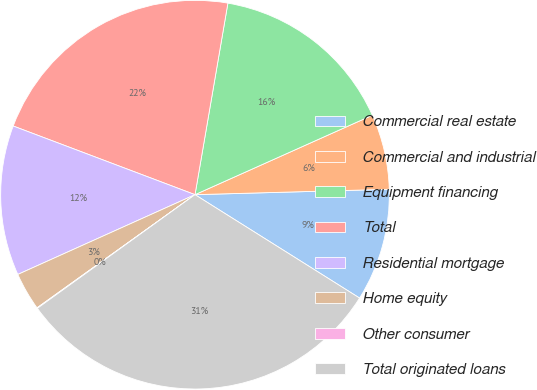Convert chart. <chart><loc_0><loc_0><loc_500><loc_500><pie_chart><fcel>Commercial real estate<fcel>Commercial and industrial<fcel>Equipment financing<fcel>Total<fcel>Residential mortgage<fcel>Home equity<fcel>Other consumer<fcel>Total originated loans<nl><fcel>9.37%<fcel>6.26%<fcel>15.59%<fcel>21.96%<fcel>12.48%<fcel>3.16%<fcel>0.05%<fcel>31.13%<nl></chart> 